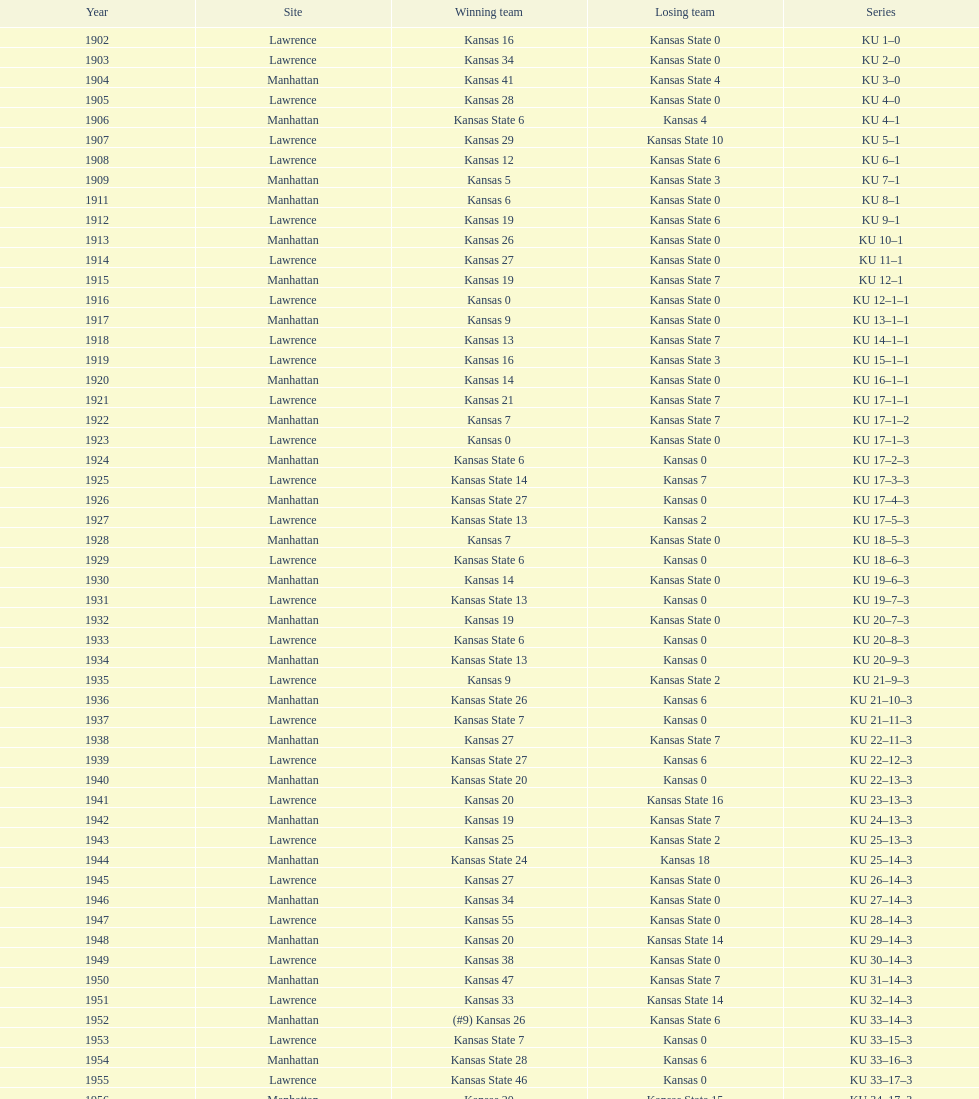Before 1910, how many victories did kansas have against kansas state? 7. 